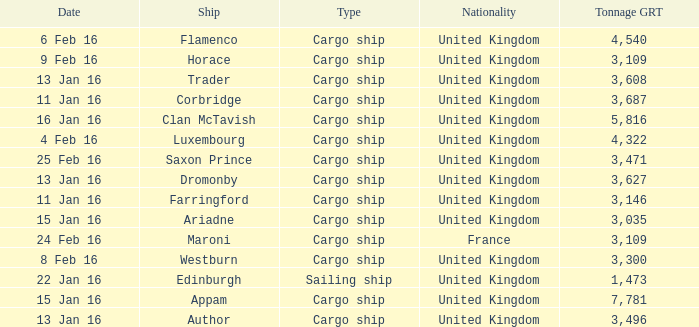What is the tonnage grt of the ship author? 3496.0. 